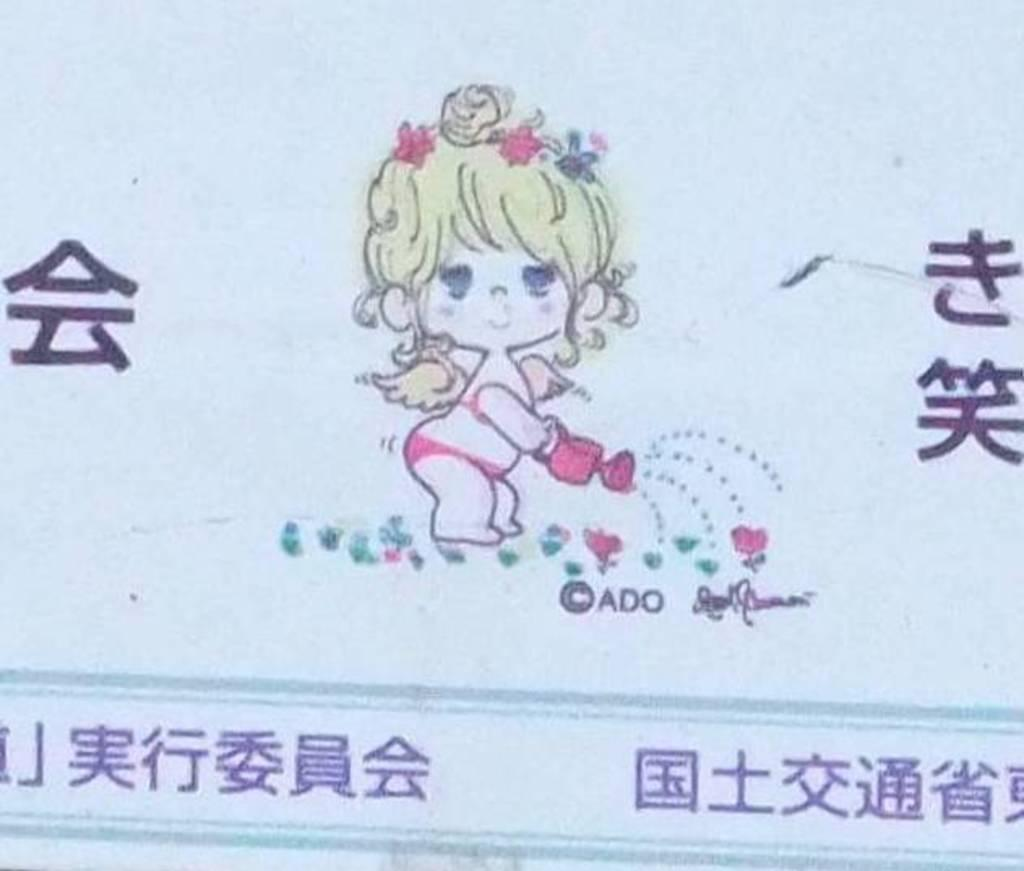What is present in the image that contains both images and text? There is a poster in the image that contains images and text. What type of voice can be heard coming from the poster in the image? There is no voice present in the image, as it is a static poster containing images and text. 